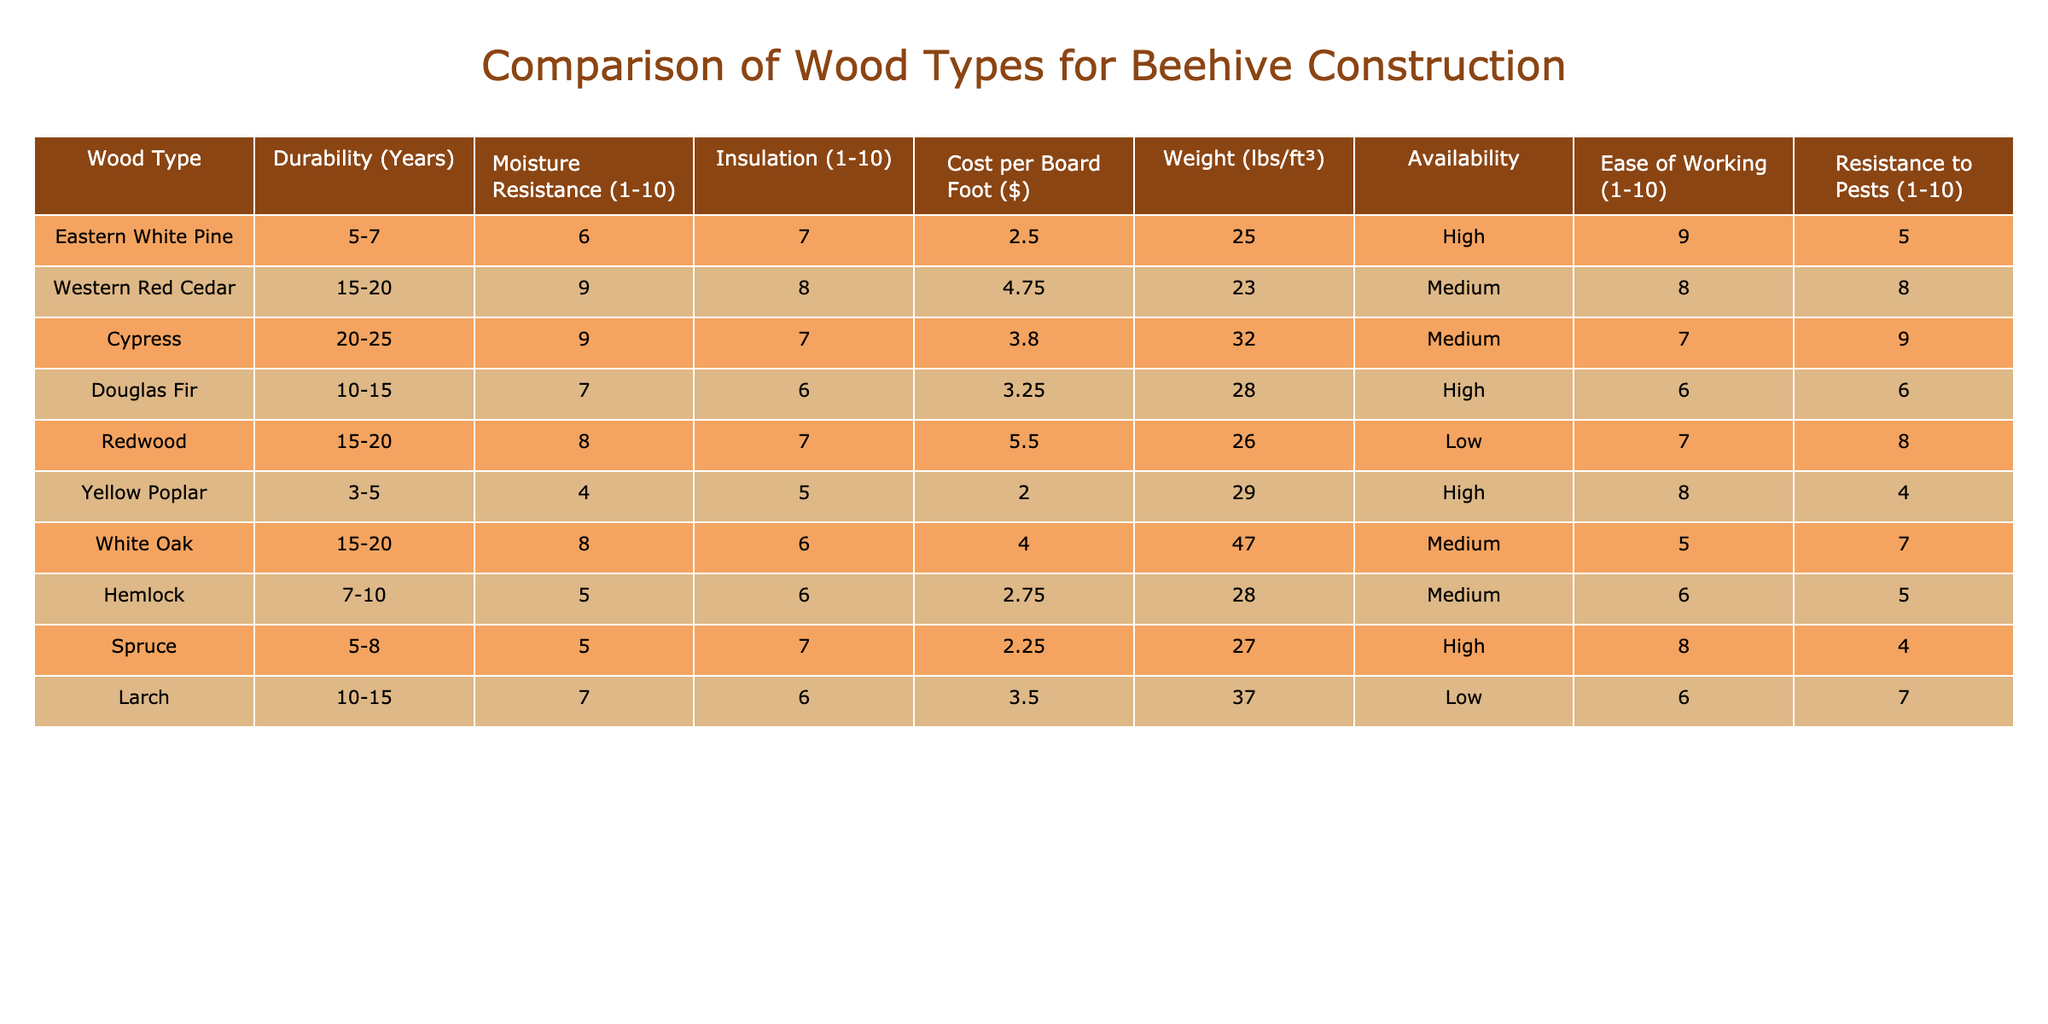What is the durability range of Cypress wood? The table lists the durability of Cypress wood as "20-25" years.
Answer: 20-25 years Which wood type has the highest moisture resistance? By comparing the moisture resistance ratings in the table, Cypress and Western Red Cedar both have a rating of 9, which is the highest.
Answer: Cypress and Western Red Cedar What is the average cost per board foot of wood types that are highly available? The cost per board foot for highly available woods (Eastern White Pine, Douglas Fir, Spruce) is 2.50, 3.25, and 2.25, respectively. The average is (2.50 + 3.25 + 2.25) / 3 = 2.67.
Answer: 2.67 Does White Oak have a higher pest resistance than Red Cedar? By checking the resistance to pests, White Oak has a rating of 7, while Western Red Cedar has a rating of 8. Thus, White Oak does not have higher pest resistance.
Answer: No Which wood type has the lowest insulation rating? Looking at the insulation ratings, Yellow Poplar has the lowest rating of 5.
Answer: Yellow Poplar If you combine the durability rating of Eastern White Pine and Redwood, what is their average durability? The durability of Eastern White Pine is 6 years (average of 5-7) and Redwood is 17.5 years (average of 15-20). The average durability is (6 + 17.5) / 2 = 11.75 years.
Answer: 11.75 years Is the weight of Cypress higher than that of Spruce? The table records Cypress at 32 lbs/ft³ and Spruce at 27 lbs/ft³. Since 32 is greater than 27, Cypress is heavier.
Answer: Yes Which wood type has the best ease of working score? By checking the ease of working scores, Eastern White Pine has the highest score of 9.
Answer: Eastern White Pine What is the total moisture resistance score of all wood types listed? To find this, sum up all the individual moisture resistance scores: 6 + 9 + 9 + 7 + 8 + 4 + 8 + 5 + 5 + 7 = 66.
Answer: 66 Which wood types have a combined durability of over 30 years? The only wood types that have a combined durability over 30 years are Cypress (20-25 years) and Western Red Cedar (15-20 years). The upper estimates exceed 30 years.
Answer: Cypress and Western Red Cedar 